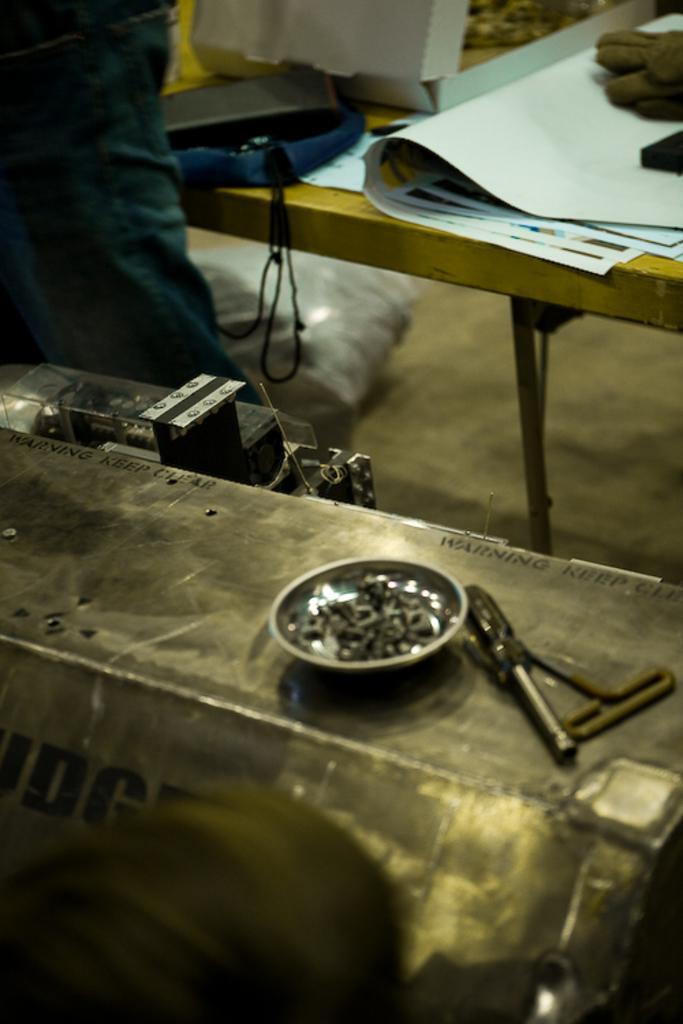Please provide a concise description of this image. In this picture, there is a metal in the center. On the metal, there are some objects. At the bottom, there is a person. On the top, there is a person wearing a green shirt. Before him, there is a table. On the table, there are some objects. 